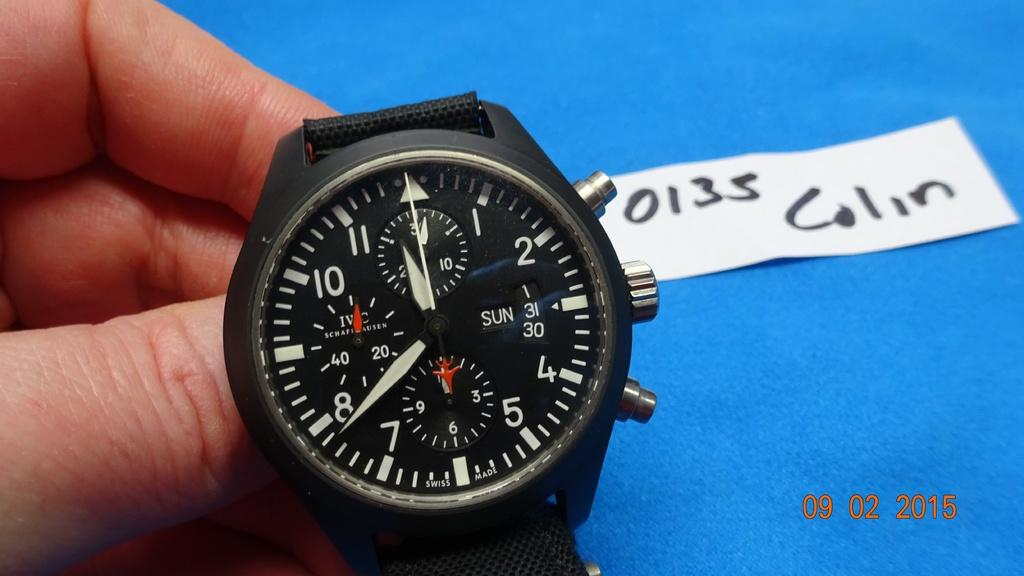<image>
Relay a brief, clear account of the picture shown. A watch is presented with a 0135 Colin label. 